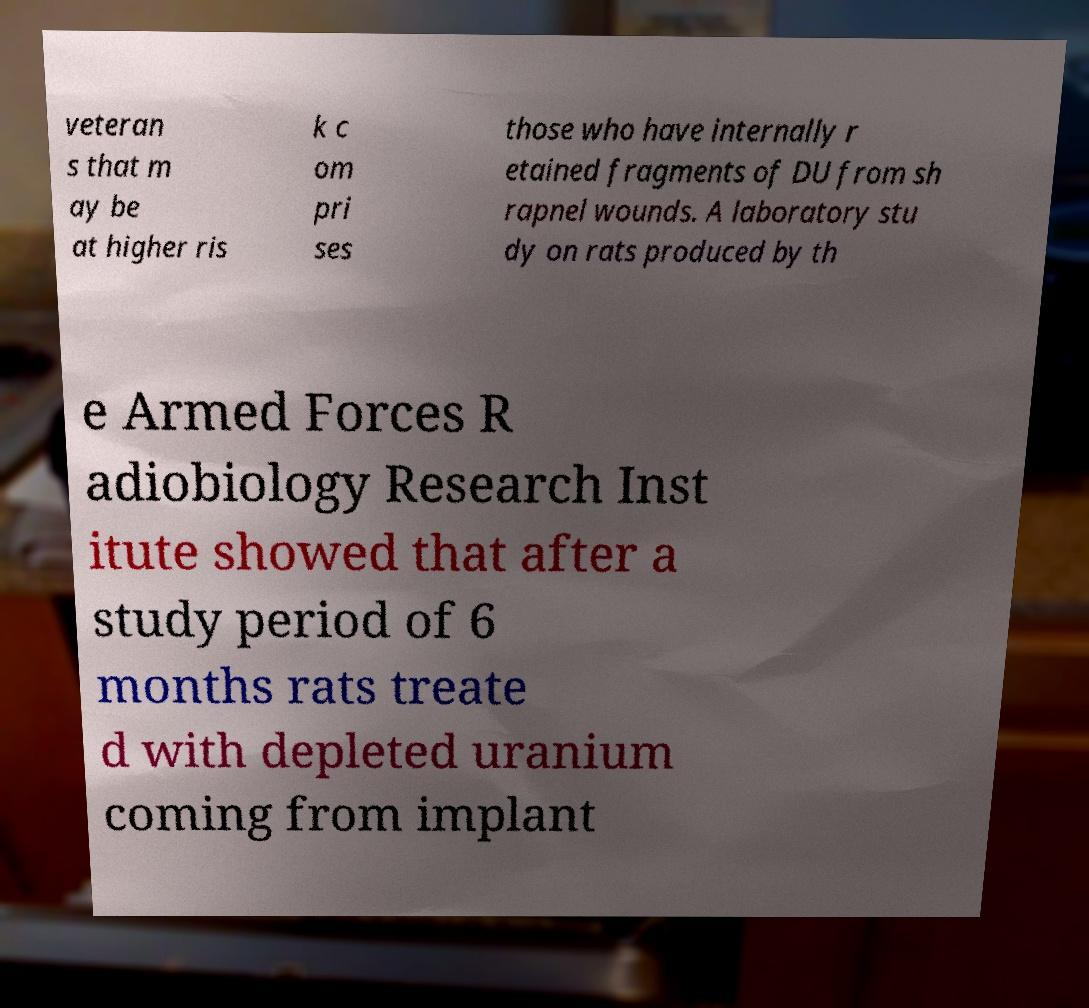What messages or text are displayed in this image? I need them in a readable, typed format. veteran s that m ay be at higher ris k c om pri ses those who have internally r etained fragments of DU from sh rapnel wounds. A laboratory stu dy on rats produced by th e Armed Forces R adiobiology Research Inst itute showed that after a study period of 6 months rats treate d with depleted uranium coming from implant 